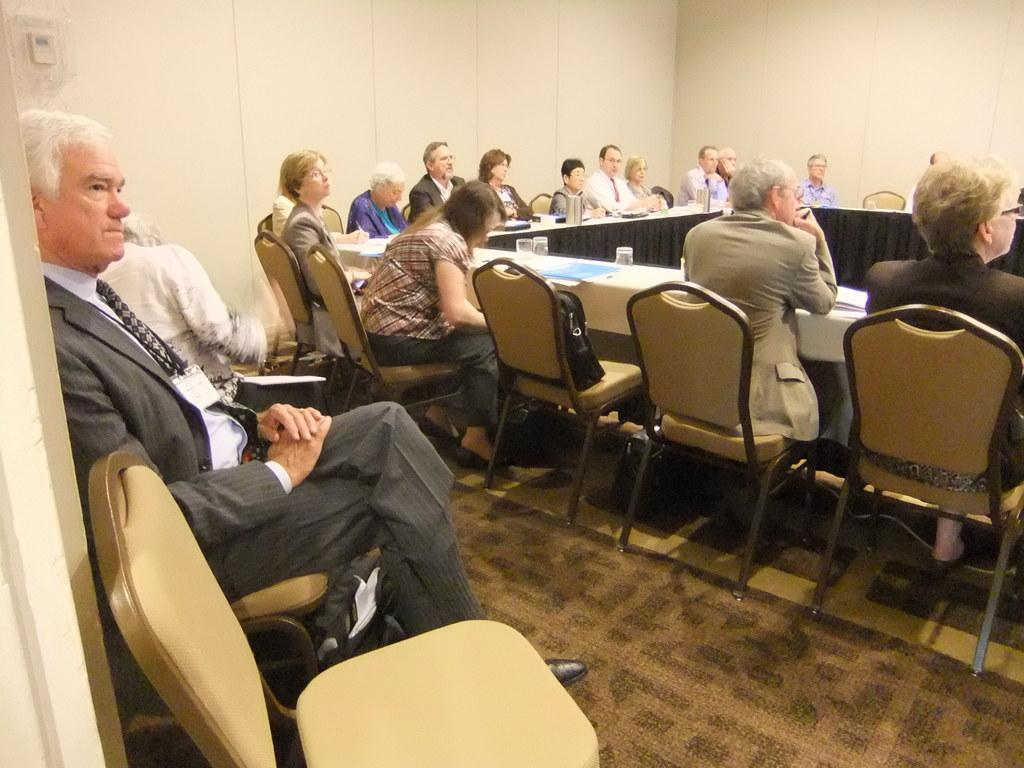What are the people in the image doing? The people in the image are sitting in chairs at a table. Are there any other people in the image besides those at the table? Yes, there are additional people beside the table. What type of basketball is being used by the people in the image? There is no basketball present in the image; the people are sitting at a table. 